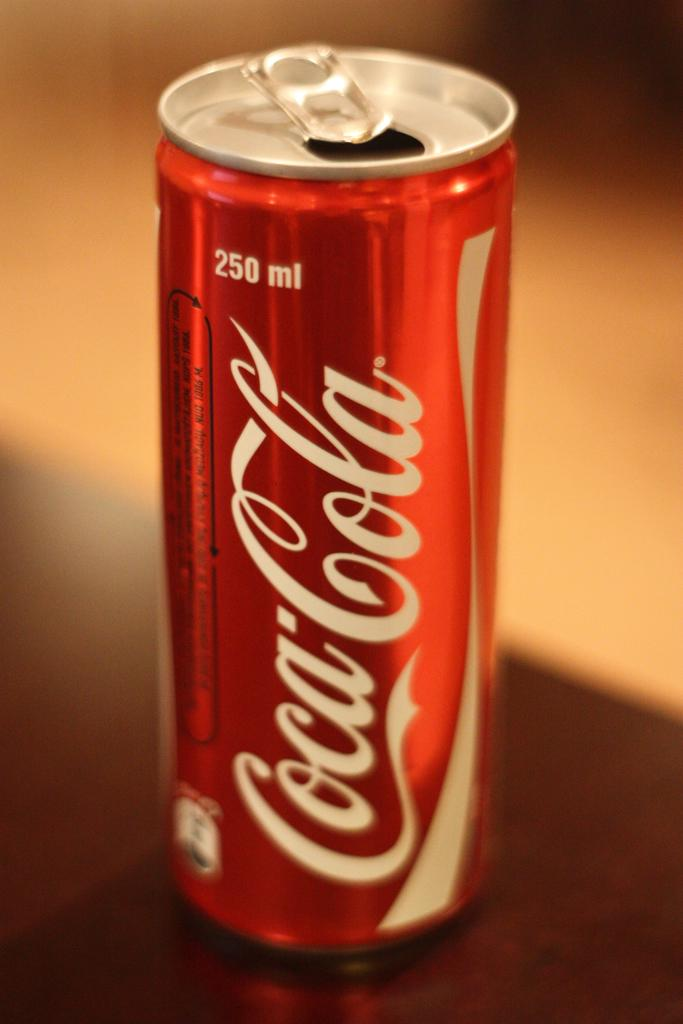Provide a one-sentence caption for the provided image. A 250 ml Coca Cola can sitting on a table. 